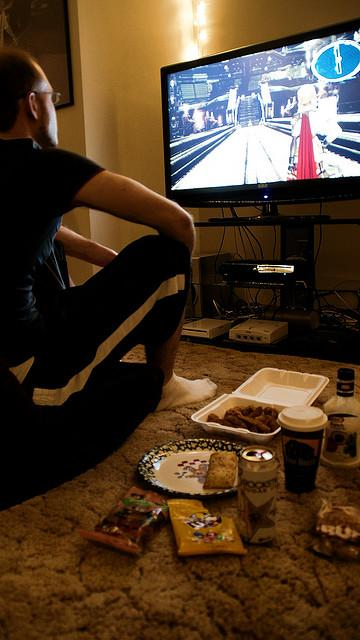What type dressing does this man favor?

Choices:
A) ranch
B) green goddess
C) thousand island
D) french ranch 